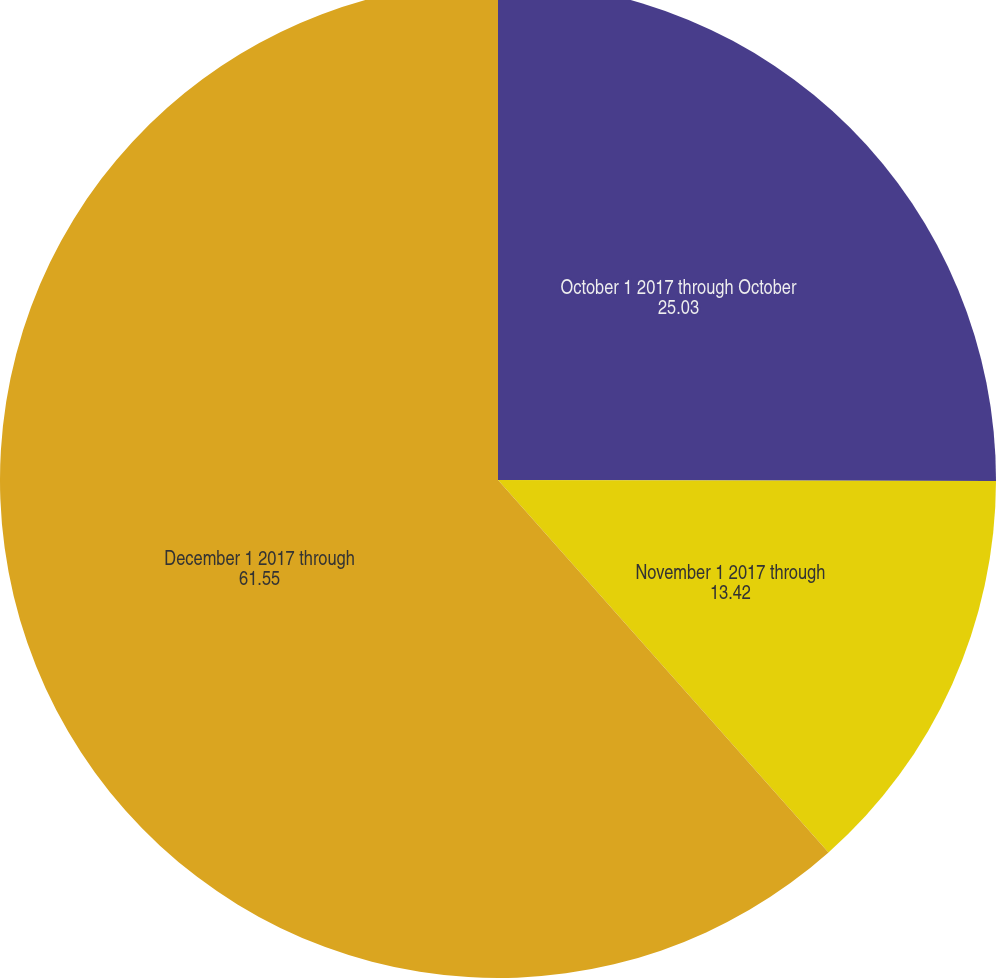Convert chart. <chart><loc_0><loc_0><loc_500><loc_500><pie_chart><fcel>October 1 2017 through October<fcel>November 1 2017 through<fcel>December 1 2017 through<nl><fcel>25.03%<fcel>13.42%<fcel>61.55%<nl></chart> 